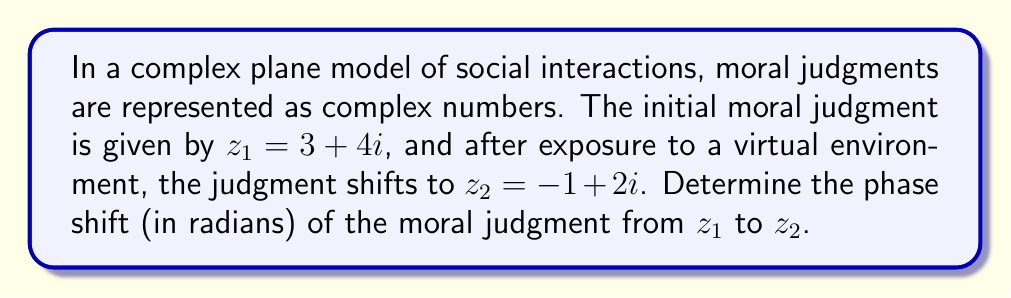Provide a solution to this math problem. To determine the phase shift between two complex numbers, we need to calculate the difference between their arguments (angles in the complex plane). Let's approach this step-by-step:

1) For a complex number $z = a + bi$, the argument is given by $\arg(z) = \tan^{-1}(\frac{b}{a})$, with appropriate quadrant adjustments.

2) For $z_1 = 3 + 4i$:
   $$\arg(z_1) = \tan^{-1}(\frac{4}{3}) \approx 0.9273 \text{ radians}$$

3) For $z_2 = -1 + 2i$:
   $$\arg(z_2) = \tan^{-1}(\frac{2}{-1}) + \pi \approx 2.0344 \text{ radians}$$
   (We add $\pi$ because $z_2$ is in the second quadrant)

4) The phase shift is the difference between these arguments:
   $$\text{Phase shift} = \arg(z_2) - \arg(z_1) \approx 2.0344 - 0.9273 \approx 1.1071 \text{ radians}$$

In the context of moral decision-making, this phase shift represents a significant change in the moral judgment after exposure to the virtual environment. The positive shift indicates a counterclockwise rotation in the complex plane, which could be interpreted as a shift towards a different moral perspective or value system in the virtual context.
Answer: The phase shift of the moral judgment is approximately 1.1071 radians. 